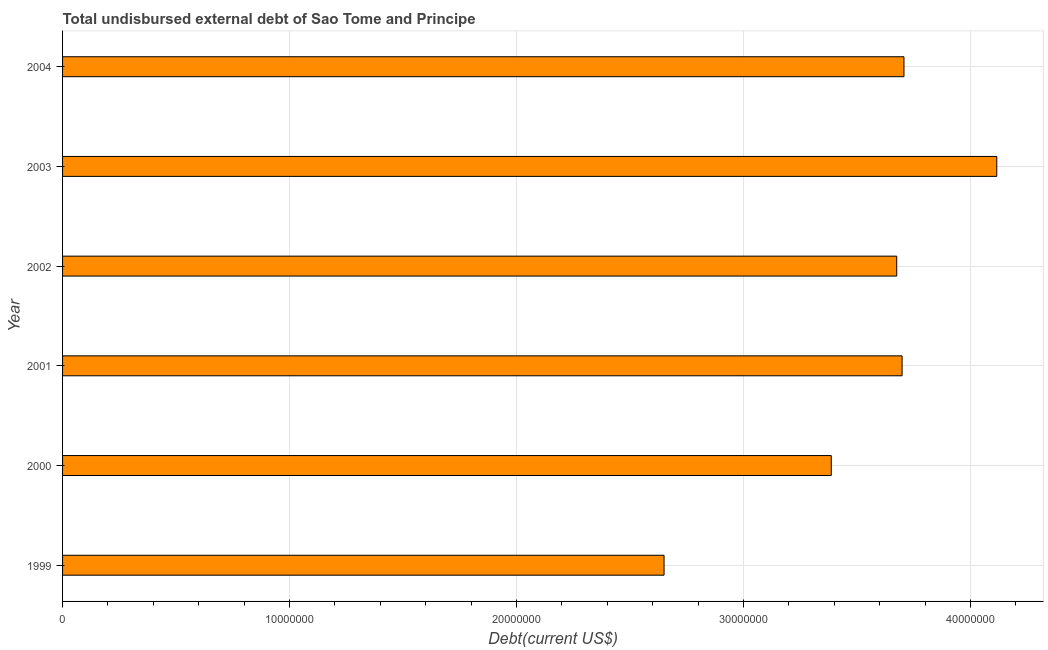Does the graph contain grids?
Keep it short and to the point. Yes. What is the title of the graph?
Your answer should be very brief. Total undisbursed external debt of Sao Tome and Principe. What is the label or title of the X-axis?
Make the answer very short. Debt(current US$). What is the label or title of the Y-axis?
Offer a terse response. Year. What is the total debt in 2002?
Offer a terse response. 3.68e+07. Across all years, what is the maximum total debt?
Your answer should be compact. 4.12e+07. Across all years, what is the minimum total debt?
Provide a short and direct response. 2.65e+07. In which year was the total debt maximum?
Ensure brevity in your answer.  2003. In which year was the total debt minimum?
Keep it short and to the point. 1999. What is the sum of the total debt?
Give a very brief answer. 2.12e+08. What is the difference between the total debt in 1999 and 2002?
Ensure brevity in your answer.  -1.03e+07. What is the average total debt per year?
Your answer should be compact. 3.54e+07. What is the median total debt?
Offer a very short reply. 3.69e+07. Do a majority of the years between 2003 and 2001 (inclusive) have total debt greater than 14000000 US$?
Your answer should be compact. Yes. What is the ratio of the total debt in 2000 to that in 2004?
Your response must be concise. 0.91. Is the total debt in 1999 less than that in 2002?
Your answer should be very brief. Yes. What is the difference between the highest and the second highest total debt?
Offer a very short reply. 4.09e+06. What is the difference between the highest and the lowest total debt?
Provide a succinct answer. 1.47e+07. Are the values on the major ticks of X-axis written in scientific E-notation?
Provide a succinct answer. No. What is the Debt(current US$) in 1999?
Give a very brief answer. 2.65e+07. What is the Debt(current US$) of 2000?
Offer a terse response. 3.39e+07. What is the Debt(current US$) in 2001?
Ensure brevity in your answer.  3.70e+07. What is the Debt(current US$) in 2002?
Make the answer very short. 3.68e+07. What is the Debt(current US$) of 2003?
Provide a short and direct response. 4.12e+07. What is the Debt(current US$) in 2004?
Offer a terse response. 3.71e+07. What is the difference between the Debt(current US$) in 1999 and 2000?
Give a very brief answer. -7.37e+06. What is the difference between the Debt(current US$) in 1999 and 2001?
Your answer should be very brief. -1.05e+07. What is the difference between the Debt(current US$) in 1999 and 2002?
Offer a terse response. -1.03e+07. What is the difference between the Debt(current US$) in 1999 and 2003?
Your response must be concise. -1.47e+07. What is the difference between the Debt(current US$) in 1999 and 2004?
Offer a very short reply. -1.06e+07. What is the difference between the Debt(current US$) in 2000 and 2001?
Your answer should be very brief. -3.12e+06. What is the difference between the Debt(current US$) in 2000 and 2002?
Provide a succinct answer. -2.88e+06. What is the difference between the Debt(current US$) in 2000 and 2003?
Provide a succinct answer. -7.29e+06. What is the difference between the Debt(current US$) in 2000 and 2004?
Your answer should be very brief. -3.20e+06. What is the difference between the Debt(current US$) in 2001 and 2002?
Offer a terse response. 2.36e+05. What is the difference between the Debt(current US$) in 2001 and 2003?
Make the answer very short. -4.17e+06. What is the difference between the Debt(current US$) in 2001 and 2004?
Offer a terse response. -8.30e+04. What is the difference between the Debt(current US$) in 2002 and 2003?
Your answer should be very brief. -4.41e+06. What is the difference between the Debt(current US$) in 2002 and 2004?
Make the answer very short. -3.19e+05. What is the difference between the Debt(current US$) in 2003 and 2004?
Keep it short and to the point. 4.09e+06. What is the ratio of the Debt(current US$) in 1999 to that in 2000?
Give a very brief answer. 0.78. What is the ratio of the Debt(current US$) in 1999 to that in 2001?
Give a very brief answer. 0.72. What is the ratio of the Debt(current US$) in 1999 to that in 2002?
Keep it short and to the point. 0.72. What is the ratio of the Debt(current US$) in 1999 to that in 2003?
Your answer should be compact. 0.64. What is the ratio of the Debt(current US$) in 1999 to that in 2004?
Give a very brief answer. 0.71. What is the ratio of the Debt(current US$) in 2000 to that in 2001?
Make the answer very short. 0.92. What is the ratio of the Debt(current US$) in 2000 to that in 2002?
Your response must be concise. 0.92. What is the ratio of the Debt(current US$) in 2000 to that in 2003?
Keep it short and to the point. 0.82. What is the ratio of the Debt(current US$) in 2000 to that in 2004?
Give a very brief answer. 0.91. What is the ratio of the Debt(current US$) in 2001 to that in 2003?
Offer a terse response. 0.9. What is the ratio of the Debt(current US$) in 2001 to that in 2004?
Offer a terse response. 1. What is the ratio of the Debt(current US$) in 2002 to that in 2003?
Your answer should be very brief. 0.89. What is the ratio of the Debt(current US$) in 2003 to that in 2004?
Your answer should be very brief. 1.11. 